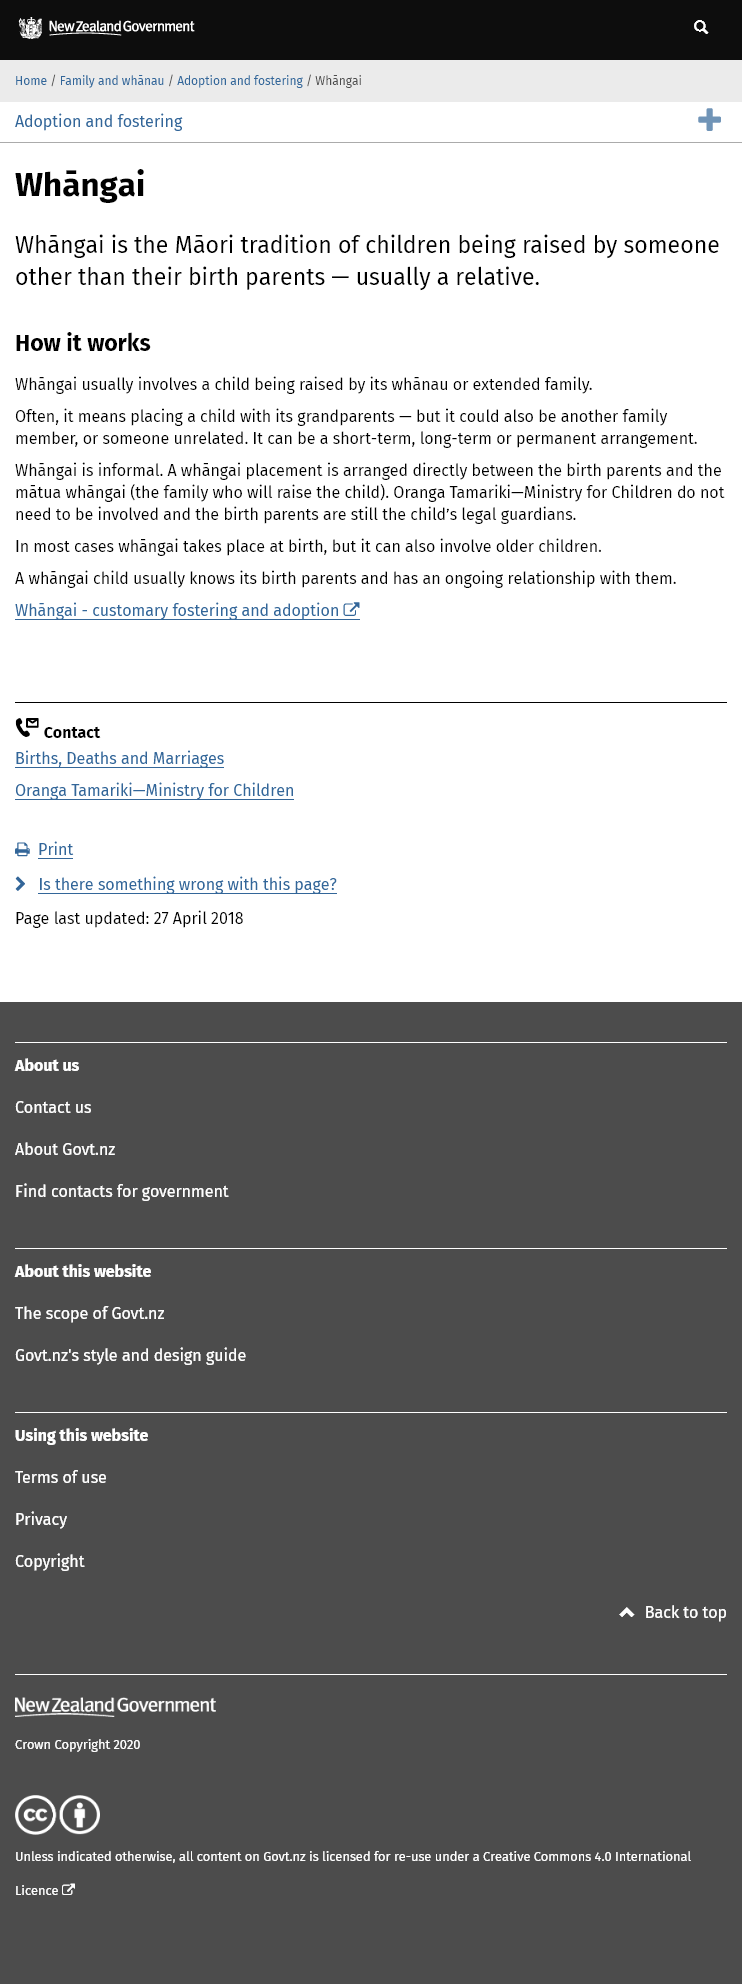Outline some significant characteristics in this image. The child may live with the matua whangai on a short-term, long term, or permanent basis. The term "whangai" comes from the Maori people. The tradition of a child being raised by someone other than their birth parents is known as whangai. 